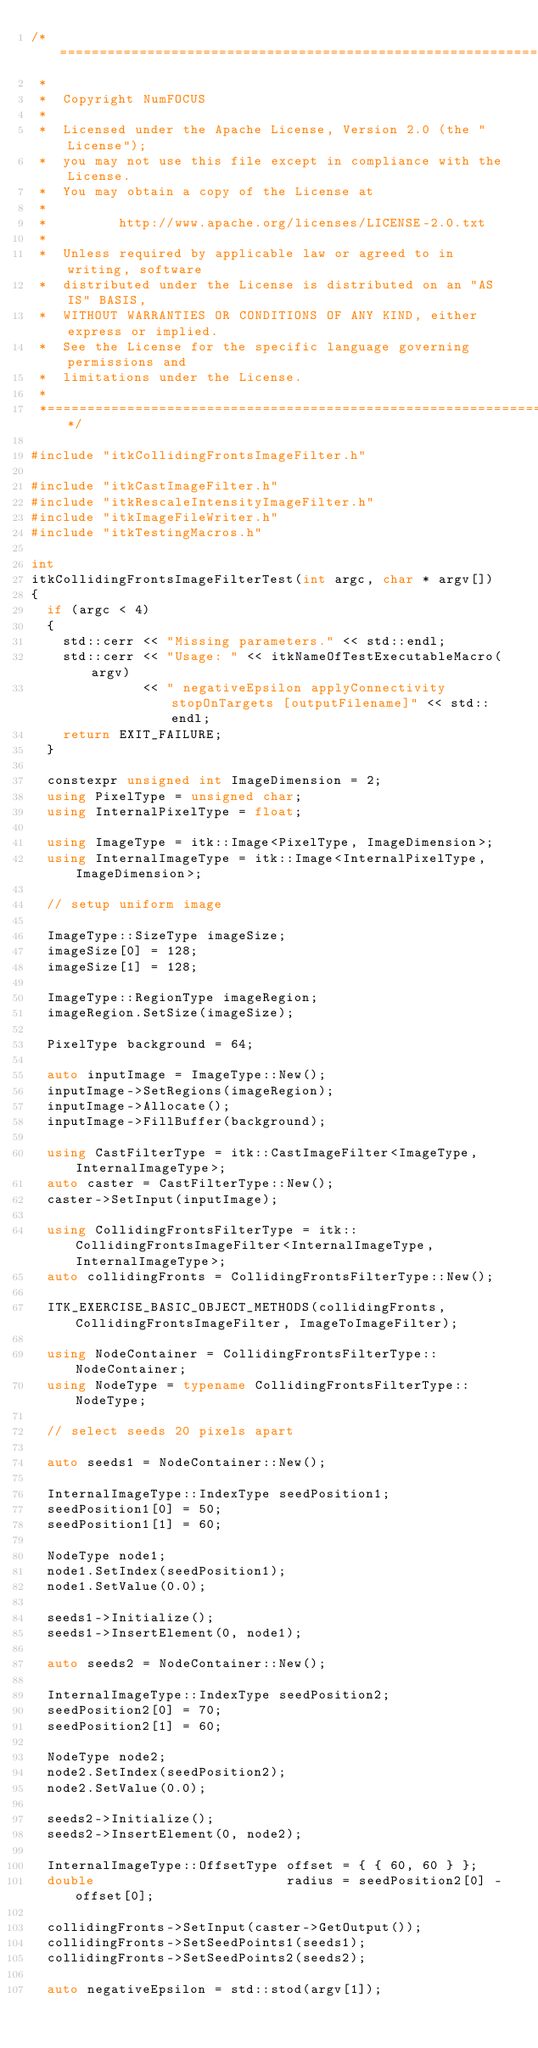<code> <loc_0><loc_0><loc_500><loc_500><_C++_>/*=========================================================================
 *
 *  Copyright NumFOCUS
 *
 *  Licensed under the Apache License, Version 2.0 (the "License");
 *  you may not use this file except in compliance with the License.
 *  You may obtain a copy of the License at
 *
 *         http://www.apache.org/licenses/LICENSE-2.0.txt
 *
 *  Unless required by applicable law or agreed to in writing, software
 *  distributed under the License is distributed on an "AS IS" BASIS,
 *  WITHOUT WARRANTIES OR CONDITIONS OF ANY KIND, either express or implied.
 *  See the License for the specific language governing permissions and
 *  limitations under the License.
 *
 *=========================================================================*/

#include "itkCollidingFrontsImageFilter.h"

#include "itkCastImageFilter.h"
#include "itkRescaleIntensityImageFilter.h"
#include "itkImageFileWriter.h"
#include "itkTestingMacros.h"

int
itkCollidingFrontsImageFilterTest(int argc, char * argv[])
{
  if (argc < 4)
  {
    std::cerr << "Missing parameters." << std::endl;
    std::cerr << "Usage: " << itkNameOfTestExecutableMacro(argv)
              << " negativeEpsilon applyConnectivity stopOnTargets [outputFilename]" << std::endl;
    return EXIT_FAILURE;
  }

  constexpr unsigned int ImageDimension = 2;
  using PixelType = unsigned char;
  using InternalPixelType = float;

  using ImageType = itk::Image<PixelType, ImageDimension>;
  using InternalImageType = itk::Image<InternalPixelType, ImageDimension>;

  // setup uniform image

  ImageType::SizeType imageSize;
  imageSize[0] = 128;
  imageSize[1] = 128;

  ImageType::RegionType imageRegion;
  imageRegion.SetSize(imageSize);

  PixelType background = 64;

  auto inputImage = ImageType::New();
  inputImage->SetRegions(imageRegion);
  inputImage->Allocate();
  inputImage->FillBuffer(background);

  using CastFilterType = itk::CastImageFilter<ImageType, InternalImageType>;
  auto caster = CastFilterType::New();
  caster->SetInput(inputImage);

  using CollidingFrontsFilterType = itk::CollidingFrontsImageFilter<InternalImageType, InternalImageType>;
  auto collidingFronts = CollidingFrontsFilterType::New();

  ITK_EXERCISE_BASIC_OBJECT_METHODS(collidingFronts, CollidingFrontsImageFilter, ImageToImageFilter);

  using NodeContainer = CollidingFrontsFilterType::NodeContainer;
  using NodeType = typename CollidingFrontsFilterType::NodeType;

  // select seeds 20 pixels apart

  auto seeds1 = NodeContainer::New();

  InternalImageType::IndexType seedPosition1;
  seedPosition1[0] = 50;
  seedPosition1[1] = 60;

  NodeType node1;
  node1.SetIndex(seedPosition1);
  node1.SetValue(0.0);

  seeds1->Initialize();
  seeds1->InsertElement(0, node1);

  auto seeds2 = NodeContainer::New();

  InternalImageType::IndexType seedPosition2;
  seedPosition2[0] = 70;
  seedPosition2[1] = 60;

  NodeType node2;
  node2.SetIndex(seedPosition2);
  node2.SetValue(0.0);

  seeds2->Initialize();
  seeds2->InsertElement(0, node2);

  InternalImageType::OffsetType offset = { { 60, 60 } };
  double                        radius = seedPosition2[0] - offset[0];

  collidingFronts->SetInput(caster->GetOutput());
  collidingFronts->SetSeedPoints1(seeds1);
  collidingFronts->SetSeedPoints2(seeds2);

  auto negativeEpsilon = std::stod(argv[1]);</code> 